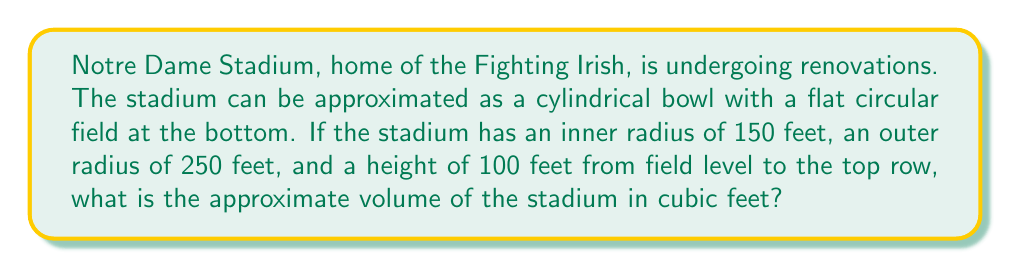Could you help me with this problem? To solve this problem, we'll use the formula for the volume of a hollow cylinder:

$$V = \pi h (R^2 - r^2)$$

Where:
$V$ = volume
$h$ = height
$R$ = outer radius
$r$ = inner radius

Step 1: Identify the given values
$h = 100$ feet
$R = 250$ feet
$r = 150$ feet

Step 2: Substitute these values into the formula
$$V = \pi \cdot 100 \cdot (250^2 - 150^2)$$

Step 3: Simplify the expression inside the parentheses
$$V = 100\pi \cdot (62,500 - 22,500)$$
$$V = 100\pi \cdot 40,000$$

Step 4: Multiply
$$V = 4,000,000\pi$$

Step 5: Calculate the final value (rounded to the nearest whole number)
$$V \approx 12,566,371 \text{ cubic feet}$$

[asy]
import geometry;

size(200);
real r1 = 3;
real r2 = 5;
real h = 2;

path p1 = circle((0,0),r1);
path p2 = circle((0,0),r2);

fill(p2^^reverse(p1),lightgray);
draw(p1);
draw(p2);

draw((r1,0)--(r1,h),dashed);
draw((r2,0)--(r2,h),dashed);
draw((r1,h)--(r2,h));

label("150 ft", (r1/2,0), S);
label("250 ft", (r1+r2/2,0), S);
label("100 ft", (r2,h/2), E);

[/asy]
Answer: $12,566,371 \text{ ft}^3$ 